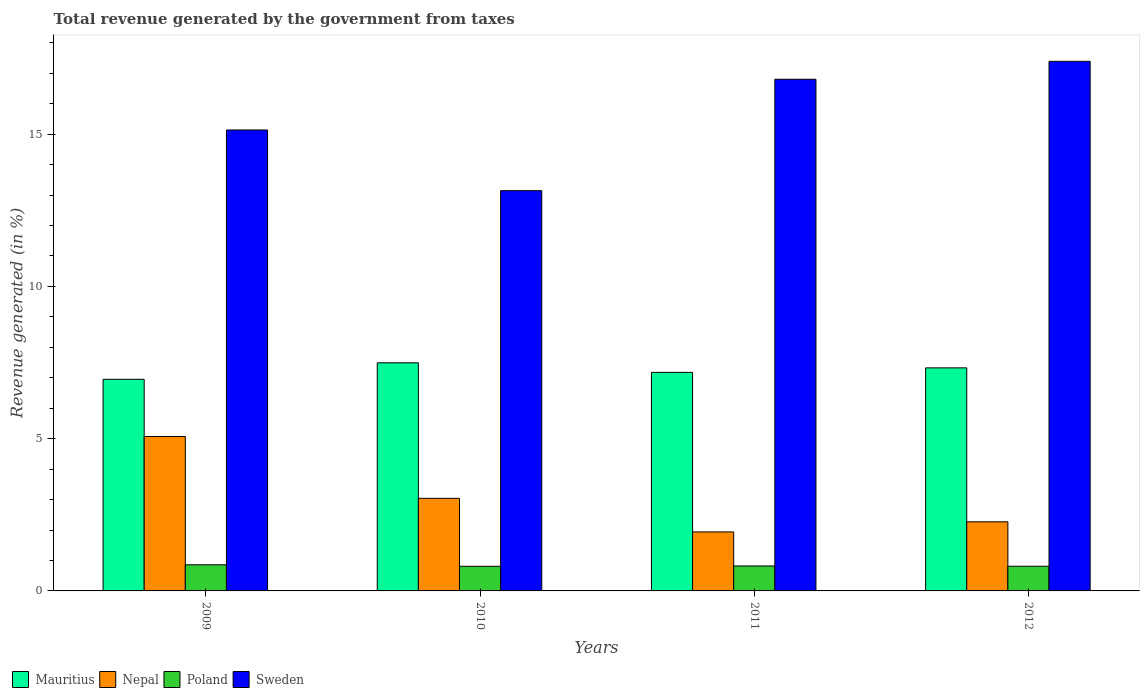How many different coloured bars are there?
Keep it short and to the point. 4. How many groups of bars are there?
Your answer should be very brief. 4. What is the label of the 1st group of bars from the left?
Your answer should be very brief. 2009. In how many cases, is the number of bars for a given year not equal to the number of legend labels?
Provide a short and direct response. 0. What is the total revenue generated in Mauritius in 2011?
Your answer should be compact. 7.18. Across all years, what is the maximum total revenue generated in Poland?
Give a very brief answer. 0.86. Across all years, what is the minimum total revenue generated in Nepal?
Your answer should be compact. 1.94. In which year was the total revenue generated in Poland maximum?
Make the answer very short. 2009. What is the total total revenue generated in Mauritius in the graph?
Provide a succinct answer. 28.94. What is the difference between the total revenue generated in Mauritius in 2011 and that in 2012?
Ensure brevity in your answer.  -0.15. What is the difference between the total revenue generated in Poland in 2011 and the total revenue generated in Nepal in 2010?
Keep it short and to the point. -2.22. What is the average total revenue generated in Poland per year?
Your answer should be compact. 0.82. In the year 2011, what is the difference between the total revenue generated in Poland and total revenue generated in Sweden?
Provide a short and direct response. -15.98. In how many years, is the total revenue generated in Sweden greater than 8 %?
Offer a very short reply. 4. What is the ratio of the total revenue generated in Nepal in 2010 to that in 2012?
Your answer should be compact. 1.34. Is the total revenue generated in Mauritius in 2011 less than that in 2012?
Provide a succinct answer. Yes. Is the difference between the total revenue generated in Poland in 2011 and 2012 greater than the difference between the total revenue generated in Sweden in 2011 and 2012?
Keep it short and to the point. Yes. What is the difference between the highest and the second highest total revenue generated in Nepal?
Keep it short and to the point. 2.03. What is the difference between the highest and the lowest total revenue generated in Sweden?
Your response must be concise. 4.25. Is the sum of the total revenue generated in Sweden in 2011 and 2012 greater than the maximum total revenue generated in Mauritius across all years?
Offer a very short reply. Yes. Is it the case that in every year, the sum of the total revenue generated in Poland and total revenue generated in Sweden is greater than the sum of total revenue generated in Nepal and total revenue generated in Mauritius?
Provide a short and direct response. No. What does the 2nd bar from the left in 2009 represents?
Offer a terse response. Nepal. What does the 3rd bar from the right in 2010 represents?
Give a very brief answer. Nepal. Is it the case that in every year, the sum of the total revenue generated in Nepal and total revenue generated in Mauritius is greater than the total revenue generated in Poland?
Offer a terse response. Yes. How many years are there in the graph?
Offer a very short reply. 4. Does the graph contain grids?
Your answer should be compact. No. Where does the legend appear in the graph?
Your answer should be compact. Bottom left. How are the legend labels stacked?
Offer a terse response. Horizontal. What is the title of the graph?
Offer a terse response. Total revenue generated by the government from taxes. What is the label or title of the X-axis?
Your response must be concise. Years. What is the label or title of the Y-axis?
Provide a short and direct response. Revenue generated (in %). What is the Revenue generated (in %) in Mauritius in 2009?
Your response must be concise. 6.95. What is the Revenue generated (in %) of Nepal in 2009?
Keep it short and to the point. 5.07. What is the Revenue generated (in %) of Poland in 2009?
Provide a succinct answer. 0.86. What is the Revenue generated (in %) in Sweden in 2009?
Provide a short and direct response. 15.14. What is the Revenue generated (in %) in Mauritius in 2010?
Make the answer very short. 7.49. What is the Revenue generated (in %) in Nepal in 2010?
Keep it short and to the point. 3.04. What is the Revenue generated (in %) of Poland in 2010?
Provide a succinct answer. 0.81. What is the Revenue generated (in %) of Sweden in 2010?
Keep it short and to the point. 13.14. What is the Revenue generated (in %) of Mauritius in 2011?
Offer a terse response. 7.18. What is the Revenue generated (in %) of Nepal in 2011?
Provide a short and direct response. 1.94. What is the Revenue generated (in %) in Poland in 2011?
Make the answer very short. 0.82. What is the Revenue generated (in %) in Sweden in 2011?
Provide a succinct answer. 16.8. What is the Revenue generated (in %) in Mauritius in 2012?
Give a very brief answer. 7.32. What is the Revenue generated (in %) in Nepal in 2012?
Make the answer very short. 2.27. What is the Revenue generated (in %) of Poland in 2012?
Offer a terse response. 0.81. What is the Revenue generated (in %) of Sweden in 2012?
Give a very brief answer. 17.39. Across all years, what is the maximum Revenue generated (in %) in Mauritius?
Your response must be concise. 7.49. Across all years, what is the maximum Revenue generated (in %) in Nepal?
Offer a terse response. 5.07. Across all years, what is the maximum Revenue generated (in %) in Poland?
Provide a succinct answer. 0.86. Across all years, what is the maximum Revenue generated (in %) in Sweden?
Your answer should be compact. 17.39. Across all years, what is the minimum Revenue generated (in %) in Mauritius?
Your answer should be very brief. 6.95. Across all years, what is the minimum Revenue generated (in %) in Nepal?
Ensure brevity in your answer.  1.94. Across all years, what is the minimum Revenue generated (in %) in Poland?
Your answer should be compact. 0.81. Across all years, what is the minimum Revenue generated (in %) of Sweden?
Ensure brevity in your answer.  13.14. What is the total Revenue generated (in %) in Mauritius in the graph?
Provide a succinct answer. 28.94. What is the total Revenue generated (in %) in Nepal in the graph?
Offer a very short reply. 12.32. What is the total Revenue generated (in %) of Poland in the graph?
Ensure brevity in your answer.  3.3. What is the total Revenue generated (in %) in Sweden in the graph?
Give a very brief answer. 62.47. What is the difference between the Revenue generated (in %) in Mauritius in 2009 and that in 2010?
Ensure brevity in your answer.  -0.54. What is the difference between the Revenue generated (in %) in Nepal in 2009 and that in 2010?
Provide a short and direct response. 2.03. What is the difference between the Revenue generated (in %) of Poland in 2009 and that in 2010?
Keep it short and to the point. 0.05. What is the difference between the Revenue generated (in %) of Sweden in 2009 and that in 2010?
Make the answer very short. 1.99. What is the difference between the Revenue generated (in %) of Mauritius in 2009 and that in 2011?
Keep it short and to the point. -0.23. What is the difference between the Revenue generated (in %) of Nepal in 2009 and that in 2011?
Give a very brief answer. 3.13. What is the difference between the Revenue generated (in %) in Poland in 2009 and that in 2011?
Provide a succinct answer. 0.04. What is the difference between the Revenue generated (in %) of Sweden in 2009 and that in 2011?
Keep it short and to the point. -1.67. What is the difference between the Revenue generated (in %) in Mauritius in 2009 and that in 2012?
Give a very brief answer. -0.38. What is the difference between the Revenue generated (in %) in Nepal in 2009 and that in 2012?
Offer a terse response. 2.8. What is the difference between the Revenue generated (in %) in Poland in 2009 and that in 2012?
Ensure brevity in your answer.  0.05. What is the difference between the Revenue generated (in %) of Sweden in 2009 and that in 2012?
Keep it short and to the point. -2.25. What is the difference between the Revenue generated (in %) in Mauritius in 2010 and that in 2011?
Offer a very short reply. 0.31. What is the difference between the Revenue generated (in %) of Nepal in 2010 and that in 2011?
Provide a short and direct response. 1.1. What is the difference between the Revenue generated (in %) in Poland in 2010 and that in 2011?
Your answer should be very brief. -0.01. What is the difference between the Revenue generated (in %) in Sweden in 2010 and that in 2011?
Give a very brief answer. -3.66. What is the difference between the Revenue generated (in %) in Mauritius in 2010 and that in 2012?
Offer a terse response. 0.17. What is the difference between the Revenue generated (in %) of Nepal in 2010 and that in 2012?
Offer a terse response. 0.77. What is the difference between the Revenue generated (in %) in Poland in 2010 and that in 2012?
Offer a terse response. -0. What is the difference between the Revenue generated (in %) of Sweden in 2010 and that in 2012?
Keep it short and to the point. -4.25. What is the difference between the Revenue generated (in %) in Mauritius in 2011 and that in 2012?
Provide a succinct answer. -0.15. What is the difference between the Revenue generated (in %) in Nepal in 2011 and that in 2012?
Keep it short and to the point. -0.33. What is the difference between the Revenue generated (in %) of Poland in 2011 and that in 2012?
Your answer should be compact. 0.01. What is the difference between the Revenue generated (in %) of Sweden in 2011 and that in 2012?
Provide a succinct answer. -0.59. What is the difference between the Revenue generated (in %) in Mauritius in 2009 and the Revenue generated (in %) in Nepal in 2010?
Your answer should be compact. 3.91. What is the difference between the Revenue generated (in %) in Mauritius in 2009 and the Revenue generated (in %) in Poland in 2010?
Provide a short and direct response. 6.14. What is the difference between the Revenue generated (in %) in Mauritius in 2009 and the Revenue generated (in %) in Sweden in 2010?
Your answer should be compact. -6.19. What is the difference between the Revenue generated (in %) of Nepal in 2009 and the Revenue generated (in %) of Poland in 2010?
Ensure brevity in your answer.  4.26. What is the difference between the Revenue generated (in %) in Nepal in 2009 and the Revenue generated (in %) in Sweden in 2010?
Your answer should be very brief. -8.07. What is the difference between the Revenue generated (in %) of Poland in 2009 and the Revenue generated (in %) of Sweden in 2010?
Provide a succinct answer. -12.29. What is the difference between the Revenue generated (in %) of Mauritius in 2009 and the Revenue generated (in %) of Nepal in 2011?
Give a very brief answer. 5.01. What is the difference between the Revenue generated (in %) in Mauritius in 2009 and the Revenue generated (in %) in Poland in 2011?
Your response must be concise. 6.13. What is the difference between the Revenue generated (in %) of Mauritius in 2009 and the Revenue generated (in %) of Sweden in 2011?
Your response must be concise. -9.85. What is the difference between the Revenue generated (in %) in Nepal in 2009 and the Revenue generated (in %) in Poland in 2011?
Ensure brevity in your answer.  4.25. What is the difference between the Revenue generated (in %) in Nepal in 2009 and the Revenue generated (in %) in Sweden in 2011?
Make the answer very short. -11.73. What is the difference between the Revenue generated (in %) in Poland in 2009 and the Revenue generated (in %) in Sweden in 2011?
Offer a very short reply. -15.94. What is the difference between the Revenue generated (in %) in Mauritius in 2009 and the Revenue generated (in %) in Nepal in 2012?
Offer a terse response. 4.68. What is the difference between the Revenue generated (in %) of Mauritius in 2009 and the Revenue generated (in %) of Poland in 2012?
Provide a succinct answer. 6.14. What is the difference between the Revenue generated (in %) of Mauritius in 2009 and the Revenue generated (in %) of Sweden in 2012?
Provide a short and direct response. -10.44. What is the difference between the Revenue generated (in %) in Nepal in 2009 and the Revenue generated (in %) in Poland in 2012?
Your response must be concise. 4.26. What is the difference between the Revenue generated (in %) in Nepal in 2009 and the Revenue generated (in %) in Sweden in 2012?
Make the answer very short. -12.32. What is the difference between the Revenue generated (in %) in Poland in 2009 and the Revenue generated (in %) in Sweden in 2012?
Offer a very short reply. -16.53. What is the difference between the Revenue generated (in %) in Mauritius in 2010 and the Revenue generated (in %) in Nepal in 2011?
Provide a succinct answer. 5.55. What is the difference between the Revenue generated (in %) in Mauritius in 2010 and the Revenue generated (in %) in Poland in 2011?
Provide a short and direct response. 6.67. What is the difference between the Revenue generated (in %) of Mauritius in 2010 and the Revenue generated (in %) of Sweden in 2011?
Offer a terse response. -9.31. What is the difference between the Revenue generated (in %) of Nepal in 2010 and the Revenue generated (in %) of Poland in 2011?
Give a very brief answer. 2.22. What is the difference between the Revenue generated (in %) in Nepal in 2010 and the Revenue generated (in %) in Sweden in 2011?
Make the answer very short. -13.76. What is the difference between the Revenue generated (in %) in Poland in 2010 and the Revenue generated (in %) in Sweden in 2011?
Your response must be concise. -15.99. What is the difference between the Revenue generated (in %) in Mauritius in 2010 and the Revenue generated (in %) in Nepal in 2012?
Make the answer very short. 5.22. What is the difference between the Revenue generated (in %) of Mauritius in 2010 and the Revenue generated (in %) of Poland in 2012?
Give a very brief answer. 6.68. What is the difference between the Revenue generated (in %) in Mauritius in 2010 and the Revenue generated (in %) in Sweden in 2012?
Offer a very short reply. -9.9. What is the difference between the Revenue generated (in %) in Nepal in 2010 and the Revenue generated (in %) in Poland in 2012?
Your response must be concise. 2.23. What is the difference between the Revenue generated (in %) in Nepal in 2010 and the Revenue generated (in %) in Sweden in 2012?
Offer a terse response. -14.35. What is the difference between the Revenue generated (in %) of Poland in 2010 and the Revenue generated (in %) of Sweden in 2012?
Offer a very short reply. -16.58. What is the difference between the Revenue generated (in %) of Mauritius in 2011 and the Revenue generated (in %) of Nepal in 2012?
Offer a very short reply. 4.91. What is the difference between the Revenue generated (in %) of Mauritius in 2011 and the Revenue generated (in %) of Poland in 2012?
Provide a short and direct response. 6.37. What is the difference between the Revenue generated (in %) in Mauritius in 2011 and the Revenue generated (in %) in Sweden in 2012?
Your answer should be very brief. -10.21. What is the difference between the Revenue generated (in %) of Nepal in 2011 and the Revenue generated (in %) of Poland in 2012?
Offer a very short reply. 1.13. What is the difference between the Revenue generated (in %) of Nepal in 2011 and the Revenue generated (in %) of Sweden in 2012?
Offer a terse response. -15.45. What is the difference between the Revenue generated (in %) in Poland in 2011 and the Revenue generated (in %) in Sweden in 2012?
Offer a terse response. -16.57. What is the average Revenue generated (in %) in Mauritius per year?
Offer a terse response. 7.24. What is the average Revenue generated (in %) of Nepal per year?
Your response must be concise. 3.08. What is the average Revenue generated (in %) of Poland per year?
Keep it short and to the point. 0.82. What is the average Revenue generated (in %) in Sweden per year?
Ensure brevity in your answer.  15.62. In the year 2009, what is the difference between the Revenue generated (in %) in Mauritius and Revenue generated (in %) in Nepal?
Provide a succinct answer. 1.88. In the year 2009, what is the difference between the Revenue generated (in %) of Mauritius and Revenue generated (in %) of Poland?
Keep it short and to the point. 6.09. In the year 2009, what is the difference between the Revenue generated (in %) of Mauritius and Revenue generated (in %) of Sweden?
Your answer should be very brief. -8.19. In the year 2009, what is the difference between the Revenue generated (in %) in Nepal and Revenue generated (in %) in Poland?
Give a very brief answer. 4.21. In the year 2009, what is the difference between the Revenue generated (in %) of Nepal and Revenue generated (in %) of Sweden?
Offer a very short reply. -10.07. In the year 2009, what is the difference between the Revenue generated (in %) of Poland and Revenue generated (in %) of Sweden?
Your answer should be very brief. -14.28. In the year 2010, what is the difference between the Revenue generated (in %) in Mauritius and Revenue generated (in %) in Nepal?
Your response must be concise. 4.45. In the year 2010, what is the difference between the Revenue generated (in %) of Mauritius and Revenue generated (in %) of Poland?
Make the answer very short. 6.68. In the year 2010, what is the difference between the Revenue generated (in %) in Mauritius and Revenue generated (in %) in Sweden?
Provide a short and direct response. -5.65. In the year 2010, what is the difference between the Revenue generated (in %) in Nepal and Revenue generated (in %) in Poland?
Give a very brief answer. 2.23. In the year 2010, what is the difference between the Revenue generated (in %) in Nepal and Revenue generated (in %) in Sweden?
Your answer should be very brief. -10.1. In the year 2010, what is the difference between the Revenue generated (in %) in Poland and Revenue generated (in %) in Sweden?
Keep it short and to the point. -12.33. In the year 2011, what is the difference between the Revenue generated (in %) of Mauritius and Revenue generated (in %) of Nepal?
Keep it short and to the point. 5.24. In the year 2011, what is the difference between the Revenue generated (in %) of Mauritius and Revenue generated (in %) of Poland?
Keep it short and to the point. 6.36. In the year 2011, what is the difference between the Revenue generated (in %) of Mauritius and Revenue generated (in %) of Sweden?
Ensure brevity in your answer.  -9.62. In the year 2011, what is the difference between the Revenue generated (in %) of Nepal and Revenue generated (in %) of Poland?
Make the answer very short. 1.12. In the year 2011, what is the difference between the Revenue generated (in %) in Nepal and Revenue generated (in %) in Sweden?
Keep it short and to the point. -14.86. In the year 2011, what is the difference between the Revenue generated (in %) of Poland and Revenue generated (in %) of Sweden?
Your answer should be compact. -15.98. In the year 2012, what is the difference between the Revenue generated (in %) in Mauritius and Revenue generated (in %) in Nepal?
Your response must be concise. 5.06. In the year 2012, what is the difference between the Revenue generated (in %) of Mauritius and Revenue generated (in %) of Poland?
Your response must be concise. 6.51. In the year 2012, what is the difference between the Revenue generated (in %) of Mauritius and Revenue generated (in %) of Sweden?
Ensure brevity in your answer.  -10.07. In the year 2012, what is the difference between the Revenue generated (in %) of Nepal and Revenue generated (in %) of Poland?
Your answer should be very brief. 1.46. In the year 2012, what is the difference between the Revenue generated (in %) in Nepal and Revenue generated (in %) in Sweden?
Offer a very short reply. -15.12. In the year 2012, what is the difference between the Revenue generated (in %) in Poland and Revenue generated (in %) in Sweden?
Make the answer very short. -16.58. What is the ratio of the Revenue generated (in %) in Mauritius in 2009 to that in 2010?
Your response must be concise. 0.93. What is the ratio of the Revenue generated (in %) of Nepal in 2009 to that in 2010?
Offer a terse response. 1.67. What is the ratio of the Revenue generated (in %) of Poland in 2009 to that in 2010?
Your response must be concise. 1.06. What is the ratio of the Revenue generated (in %) of Sweden in 2009 to that in 2010?
Ensure brevity in your answer.  1.15. What is the ratio of the Revenue generated (in %) in Mauritius in 2009 to that in 2011?
Provide a short and direct response. 0.97. What is the ratio of the Revenue generated (in %) of Nepal in 2009 to that in 2011?
Your answer should be very brief. 2.62. What is the ratio of the Revenue generated (in %) of Poland in 2009 to that in 2011?
Your answer should be compact. 1.05. What is the ratio of the Revenue generated (in %) of Sweden in 2009 to that in 2011?
Offer a very short reply. 0.9. What is the ratio of the Revenue generated (in %) in Mauritius in 2009 to that in 2012?
Provide a short and direct response. 0.95. What is the ratio of the Revenue generated (in %) of Nepal in 2009 to that in 2012?
Offer a very short reply. 2.24. What is the ratio of the Revenue generated (in %) in Poland in 2009 to that in 2012?
Your answer should be compact. 1.06. What is the ratio of the Revenue generated (in %) of Sweden in 2009 to that in 2012?
Offer a very short reply. 0.87. What is the ratio of the Revenue generated (in %) in Mauritius in 2010 to that in 2011?
Make the answer very short. 1.04. What is the ratio of the Revenue generated (in %) of Nepal in 2010 to that in 2011?
Provide a succinct answer. 1.57. What is the ratio of the Revenue generated (in %) in Poland in 2010 to that in 2011?
Ensure brevity in your answer.  0.99. What is the ratio of the Revenue generated (in %) in Sweden in 2010 to that in 2011?
Give a very brief answer. 0.78. What is the ratio of the Revenue generated (in %) in Mauritius in 2010 to that in 2012?
Provide a short and direct response. 1.02. What is the ratio of the Revenue generated (in %) of Nepal in 2010 to that in 2012?
Offer a terse response. 1.34. What is the ratio of the Revenue generated (in %) in Sweden in 2010 to that in 2012?
Make the answer very short. 0.76. What is the ratio of the Revenue generated (in %) of Mauritius in 2011 to that in 2012?
Your answer should be compact. 0.98. What is the ratio of the Revenue generated (in %) in Nepal in 2011 to that in 2012?
Keep it short and to the point. 0.85. What is the ratio of the Revenue generated (in %) of Poland in 2011 to that in 2012?
Make the answer very short. 1.01. What is the ratio of the Revenue generated (in %) in Sweden in 2011 to that in 2012?
Ensure brevity in your answer.  0.97. What is the difference between the highest and the second highest Revenue generated (in %) of Mauritius?
Offer a very short reply. 0.17. What is the difference between the highest and the second highest Revenue generated (in %) in Nepal?
Your answer should be very brief. 2.03. What is the difference between the highest and the second highest Revenue generated (in %) of Poland?
Keep it short and to the point. 0.04. What is the difference between the highest and the second highest Revenue generated (in %) in Sweden?
Ensure brevity in your answer.  0.59. What is the difference between the highest and the lowest Revenue generated (in %) of Mauritius?
Provide a short and direct response. 0.54. What is the difference between the highest and the lowest Revenue generated (in %) of Nepal?
Keep it short and to the point. 3.13. What is the difference between the highest and the lowest Revenue generated (in %) of Poland?
Give a very brief answer. 0.05. What is the difference between the highest and the lowest Revenue generated (in %) of Sweden?
Provide a short and direct response. 4.25. 